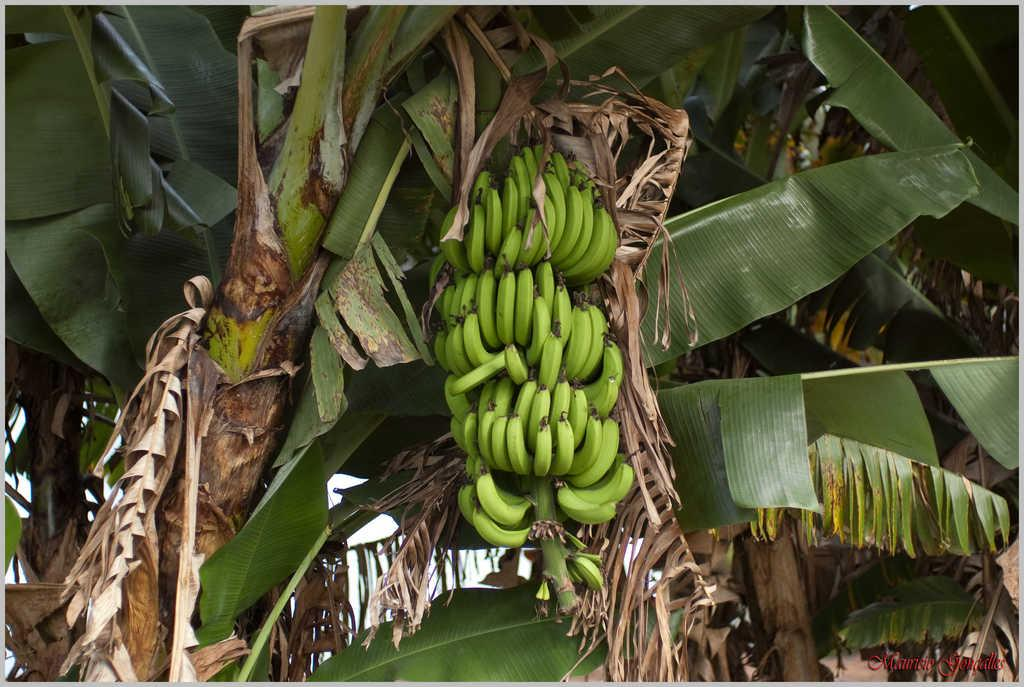What type of plant is the main subject of the image? There is a banana plant in the image. What can be seen on the banana plant? The banana plant has bananas on it. What else can be seen in the background of the image? There are many plants visible in the background of the image. Can you see any planes flying over the banana plant in the image? There is no mention of planes or any flying objects in the image, so it cannot be determined if they are present. 